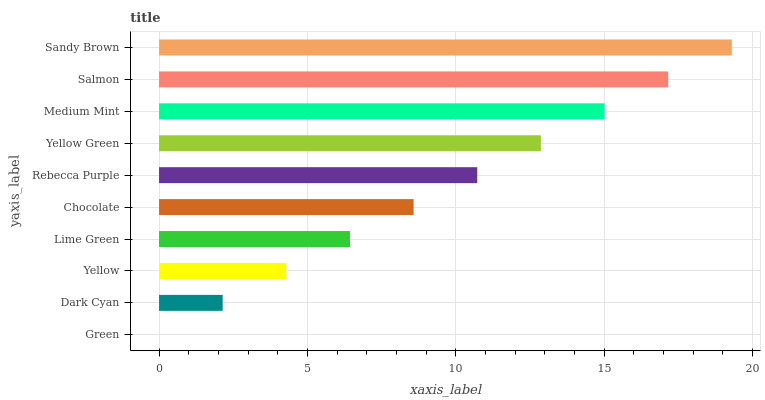Is Green the minimum?
Answer yes or no. Yes. Is Sandy Brown the maximum?
Answer yes or no. Yes. Is Dark Cyan the minimum?
Answer yes or no. No. Is Dark Cyan the maximum?
Answer yes or no. No. Is Dark Cyan greater than Green?
Answer yes or no. Yes. Is Green less than Dark Cyan?
Answer yes or no. Yes. Is Green greater than Dark Cyan?
Answer yes or no. No. Is Dark Cyan less than Green?
Answer yes or no. No. Is Rebecca Purple the high median?
Answer yes or no. Yes. Is Chocolate the low median?
Answer yes or no. Yes. Is Lime Green the high median?
Answer yes or no. No. Is Yellow the low median?
Answer yes or no. No. 